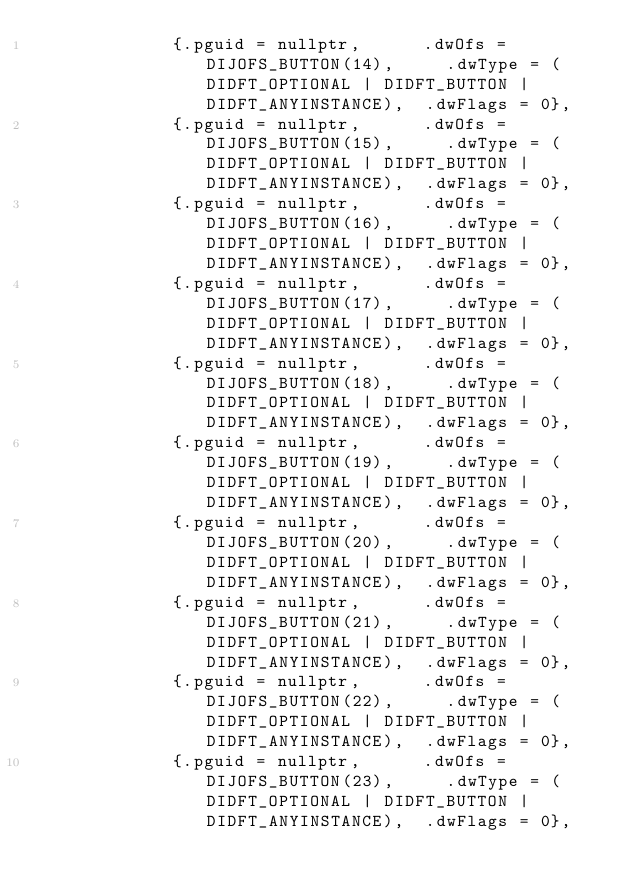<code> <loc_0><loc_0><loc_500><loc_500><_C++_>             {.pguid = nullptr,      .dwOfs = DIJOFS_BUTTON(14),     .dwType = (DIDFT_OPTIONAL | DIDFT_BUTTON | DIDFT_ANYINSTANCE),  .dwFlags = 0},
             {.pguid = nullptr,      .dwOfs = DIJOFS_BUTTON(15),     .dwType = (DIDFT_OPTIONAL | DIDFT_BUTTON | DIDFT_ANYINSTANCE),  .dwFlags = 0},
             {.pguid = nullptr,      .dwOfs = DIJOFS_BUTTON(16),     .dwType = (DIDFT_OPTIONAL | DIDFT_BUTTON | DIDFT_ANYINSTANCE),  .dwFlags = 0},
             {.pguid = nullptr,      .dwOfs = DIJOFS_BUTTON(17),     .dwType = (DIDFT_OPTIONAL | DIDFT_BUTTON | DIDFT_ANYINSTANCE),  .dwFlags = 0},
             {.pguid = nullptr,      .dwOfs = DIJOFS_BUTTON(18),     .dwType = (DIDFT_OPTIONAL | DIDFT_BUTTON | DIDFT_ANYINSTANCE),  .dwFlags = 0},
             {.pguid = nullptr,      .dwOfs = DIJOFS_BUTTON(19),     .dwType = (DIDFT_OPTIONAL | DIDFT_BUTTON | DIDFT_ANYINSTANCE),  .dwFlags = 0},
             {.pguid = nullptr,      .dwOfs = DIJOFS_BUTTON(20),     .dwType = (DIDFT_OPTIONAL | DIDFT_BUTTON | DIDFT_ANYINSTANCE),  .dwFlags = 0},
             {.pguid = nullptr,      .dwOfs = DIJOFS_BUTTON(21),     .dwType = (DIDFT_OPTIONAL | DIDFT_BUTTON | DIDFT_ANYINSTANCE),  .dwFlags = 0},
             {.pguid = nullptr,      .dwOfs = DIJOFS_BUTTON(22),     .dwType = (DIDFT_OPTIONAL | DIDFT_BUTTON | DIDFT_ANYINSTANCE),  .dwFlags = 0},
             {.pguid = nullptr,      .dwOfs = DIJOFS_BUTTON(23),     .dwType = (DIDFT_OPTIONAL | DIDFT_BUTTON | DIDFT_ANYINSTANCE),  .dwFlags = 0},</code> 